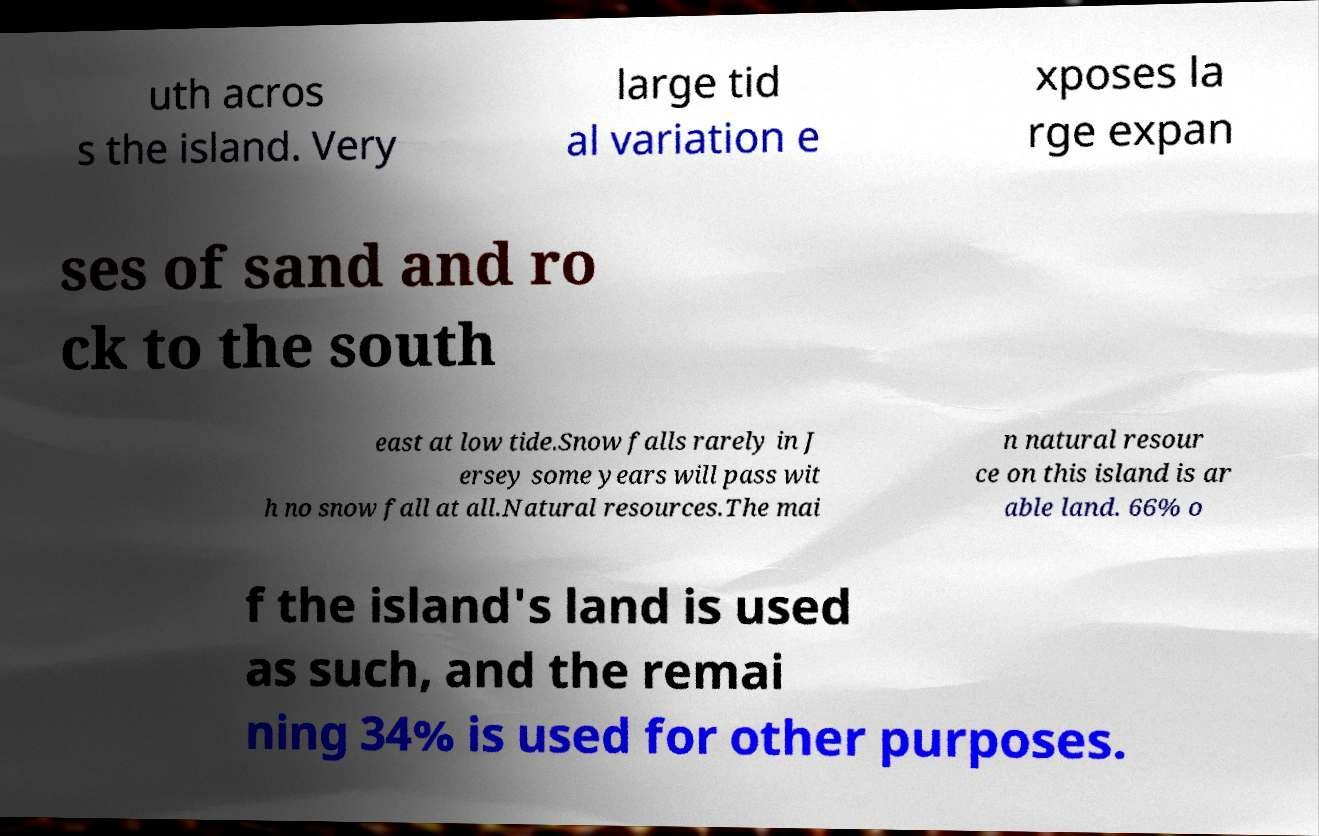There's text embedded in this image that I need extracted. Can you transcribe it verbatim? uth acros s the island. Very large tid al variation e xposes la rge expan ses of sand and ro ck to the south east at low tide.Snow falls rarely in J ersey some years will pass wit h no snow fall at all.Natural resources.The mai n natural resour ce on this island is ar able land. 66% o f the island's land is used as such, and the remai ning 34% is used for other purposes. 